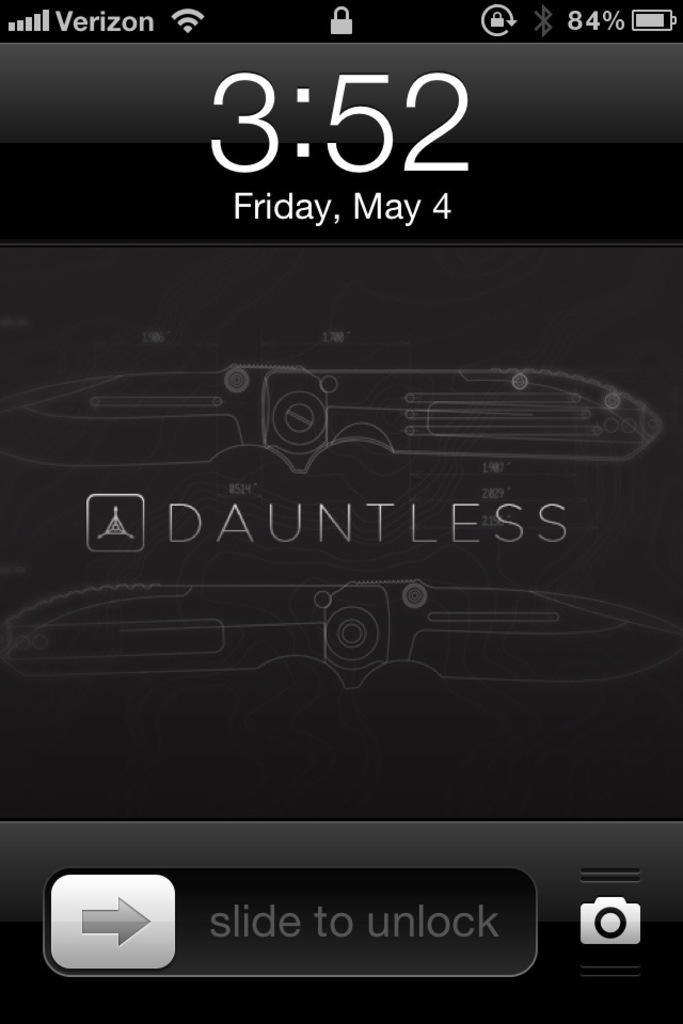Provide a one-sentence caption for the provided image. A screen shot of the lock screen of a verison phone at 3:52. 